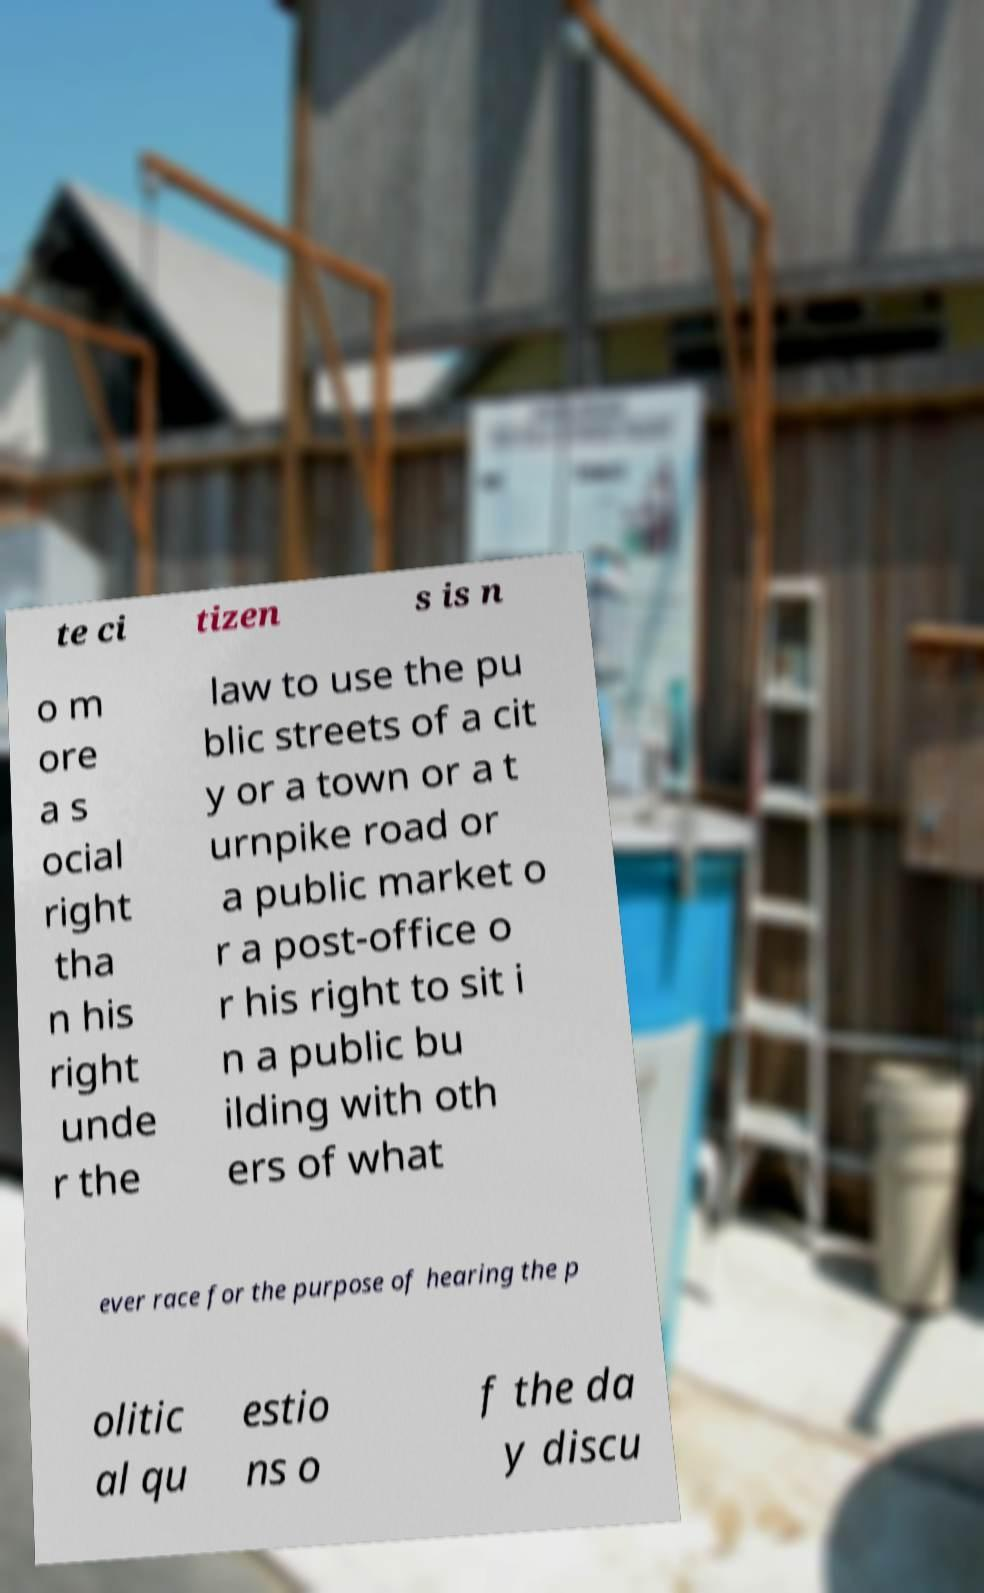Can you read and provide the text displayed in the image?This photo seems to have some interesting text. Can you extract and type it out for me? te ci tizen s is n o m ore a s ocial right tha n his right unde r the law to use the pu blic streets of a cit y or a town or a t urnpike road or a public market o r a post-office o r his right to sit i n a public bu ilding with oth ers of what ever race for the purpose of hearing the p olitic al qu estio ns o f the da y discu 